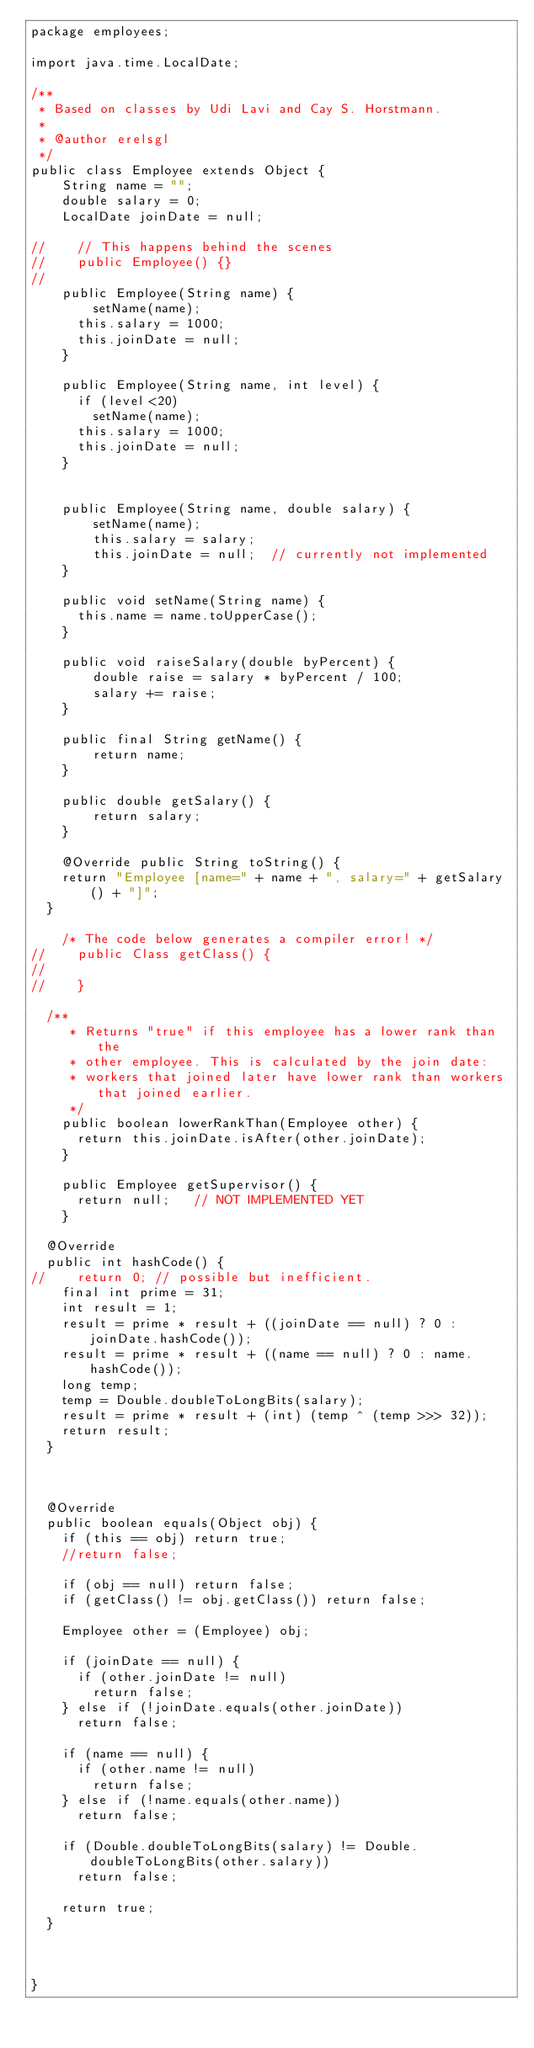Convert code to text. <code><loc_0><loc_0><loc_500><loc_500><_Java_>package employees;

import java.time.LocalDate;

/**
 * Based on classes by Udi Lavi and Cay S. Horstmann.
 * 
 * @author erelsgl
 */
public class Employee extends Object {
    String name = "";
    double salary = 0;
    LocalDate joinDate = null;
    
//    // This happens behind the scenes
//    public Employee() {}
//    
    public Employee(String name) {
        setName(name);
    	this.salary = 1000;
    	this.joinDate = null;
    }

    public Employee(String name, int level) {
    	if (level<20)
        setName(name);
    	this.salary = 1000;
    	this.joinDate = null;
    }


    public Employee(String name, double salary) {
        setName(name);
        this.salary = salary;
        this.joinDate = null;  // currently not implemented
    }
    
    public void setName(String name) {
    	this.name = name.toUpperCase();
    }

    public void raiseSalary(double byPercent) {
        double raise = salary * byPercent / 100;
        salary += raise;    
    }
    
    public final String getName() {
        return name;
    }
    
    public double getSalary() {
        return salary;
    }
    
    @Override public String toString() {
		return "Employee [name=" + name + ", salary=" + getSalary() + "]";
	}
    
    /* The code below generates a compiler error! */  
//    public Class getClass() {
//    	
//    }

	/**
     * Returns "true" if this employee has a lower rank than the 
     * other employee. This is calculated by the join date: 
     * workers that joined later have lower rank than workers that joined earlier. 
     */
    public boolean lowerRankThan(Employee other) {
    	return this.joinDate.isAfter(other.joinDate);  
    }
    
    public Employee getSupervisor() {
    	return null;   // NOT IMPLEMENTED YET  
    }

	@Override
	public int hashCode() {
//		return 0; // possible but inefficient.
		final int prime = 31;
		int result = 1;
		result = prime * result + ((joinDate == null) ? 0 : joinDate.hashCode());
		result = prime * result + ((name == null) ? 0 : name.hashCode());
		long temp;
		temp = Double.doubleToLongBits(salary);
		result = prime * result + (int) (temp ^ (temp >>> 32));
		return result;
	}

    
    
	@Override
	public boolean equals(Object obj) {
		if (this == obj) return true;
		//return false;
		
		if (obj == null) return false;
		if (getClass() != obj.getClass()) return false;
		
		Employee other = (Employee) obj;

		if (joinDate == null) {
			if (other.joinDate != null)
				return false;
		} else if (!joinDate.equals(other.joinDate))
			return false;
		
		if (name == null) {
			if (other.name != null)
				return false;
		} else if (!name.equals(other.name))
			return false;
		
		if (Double.doubleToLongBits(salary) != Double.doubleToLongBits(other.salary))
			return false;

		return true;
	}
    
   
    
}
</code> 